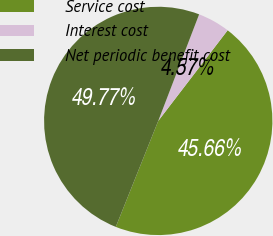<chart> <loc_0><loc_0><loc_500><loc_500><pie_chart><fcel>Service cost<fcel>Interest cost<fcel>Net periodic benefit cost<nl><fcel>45.66%<fcel>4.57%<fcel>49.77%<nl></chart> 